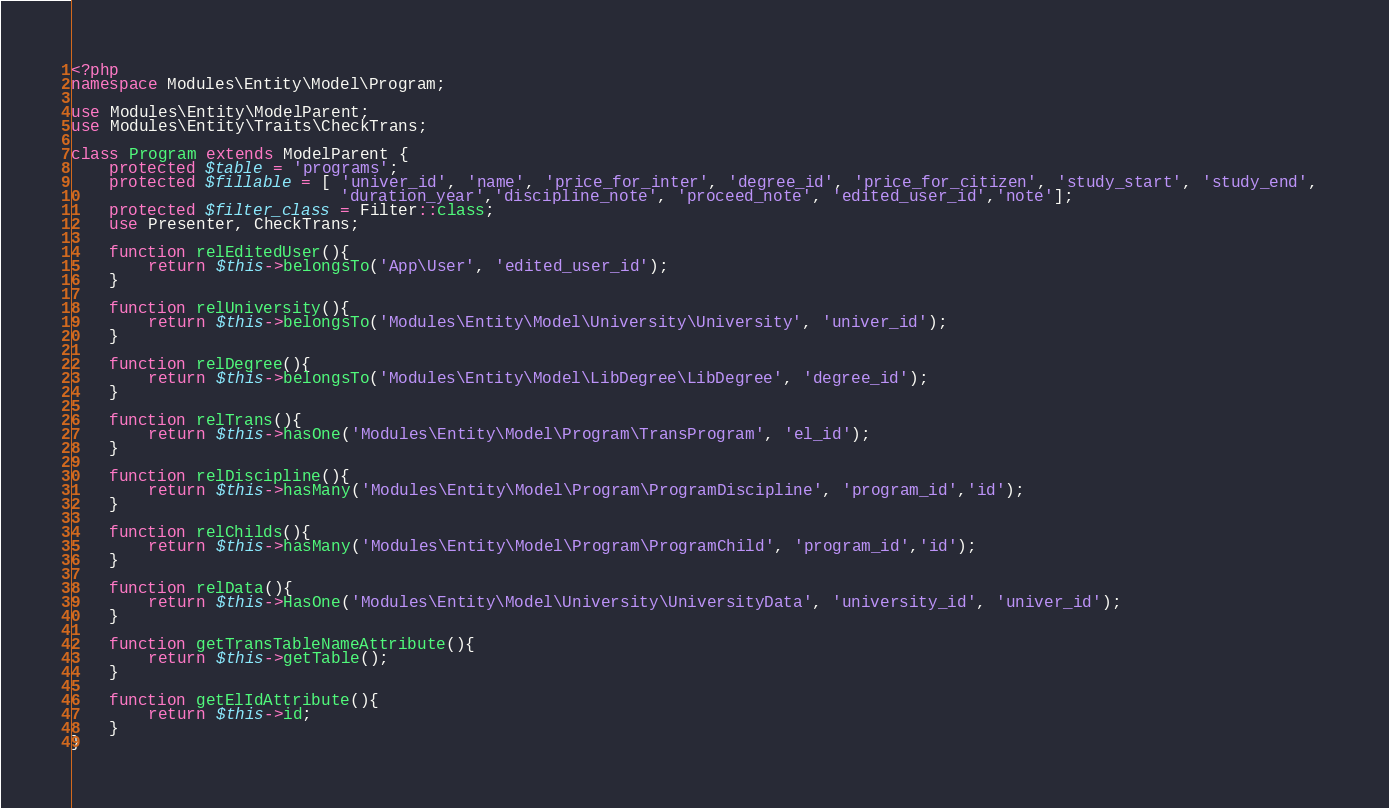Convert code to text. <code><loc_0><loc_0><loc_500><loc_500><_PHP_><?php
namespace Modules\Entity\Model\Program;

use Modules\Entity\ModelParent;
use Modules\Entity\Traits\CheckTrans;

class Program extends ModelParent {
    protected $table = 'programs';
    protected $fillable = [ 'univer_id', 'name', 'price_for_inter', 'degree_id', 'price_for_citizen', 'study_start', 'study_end', 
                            'duration_year','discipline_note', 'proceed_note', 'edited_user_id','note'];
    protected $filter_class = Filter::class; 
    use Presenter, CheckTrans;
    
    function relEditedUser(){
        return $this->belongsTo('App\User', 'edited_user_id');
    }

    function relUniversity(){
        return $this->belongsTo('Modules\Entity\Model\University\University', 'univer_id');
    }

    function relDegree(){
        return $this->belongsTo('Modules\Entity\Model\LibDegree\LibDegree', 'degree_id');
    }

    function relTrans(){
        return $this->hasOne('Modules\Entity\Model\Program\TransProgram', 'el_id');
    }

    function relDiscipline(){
        return $this->hasMany('Modules\Entity\Model\Program\ProgramDiscipline', 'program_id','id');
    }
    
    function relChilds(){
        return $this->hasMany('Modules\Entity\Model\Program\ProgramChild', 'program_id','id');
    }

    function relData(){
        return $this->HasOne('Modules\Entity\Model\University\UniversityData', 'university_id', 'univer_id');
    }
    
    function getTransTableNameAttribute(){
        return $this->getTable();
    }

    function getElIdAttribute(){
        return $this->id;
    }
}
</code> 